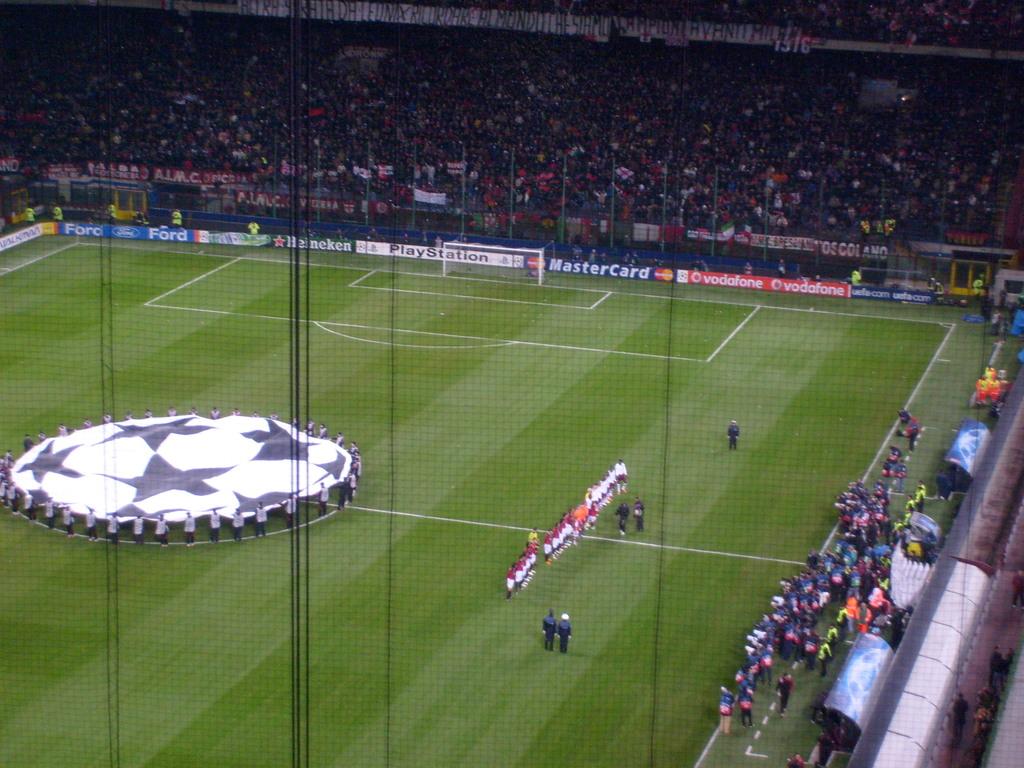What credit card is advertised?
Provide a succinct answer. Mastercard. 